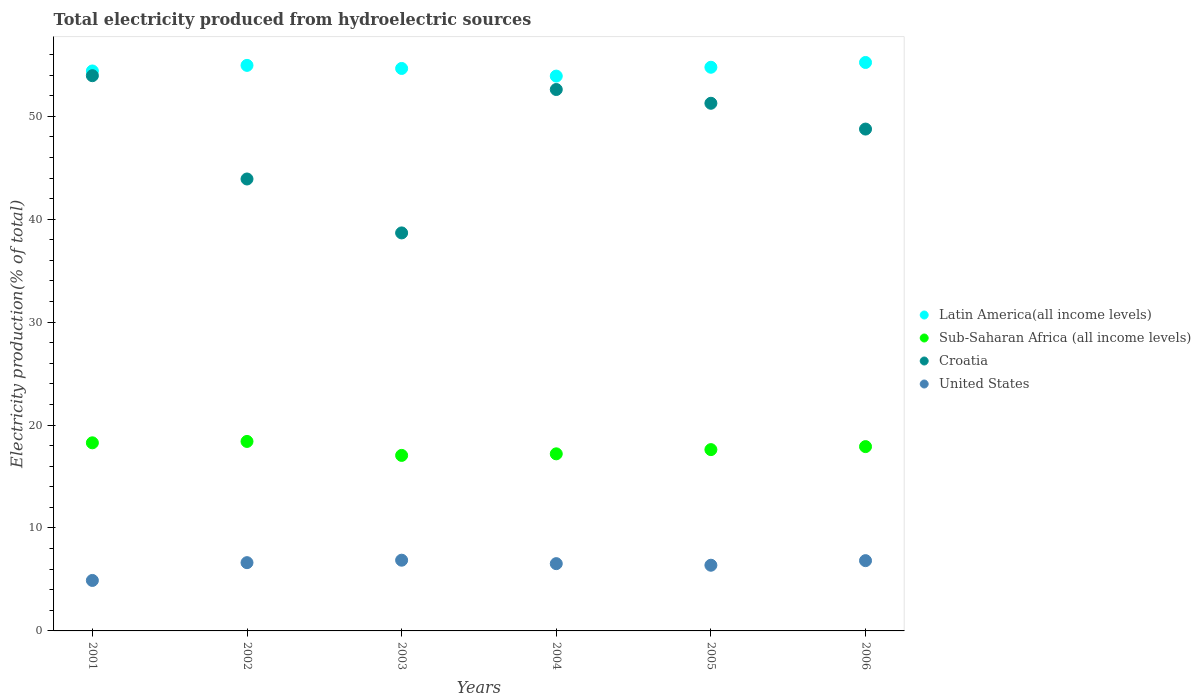How many different coloured dotlines are there?
Ensure brevity in your answer.  4. Is the number of dotlines equal to the number of legend labels?
Make the answer very short. Yes. What is the total electricity produced in Croatia in 2005?
Offer a terse response. 51.26. Across all years, what is the maximum total electricity produced in Sub-Saharan Africa (all income levels)?
Your answer should be very brief. 18.41. Across all years, what is the minimum total electricity produced in Latin America(all income levels)?
Keep it short and to the point. 53.9. In which year was the total electricity produced in United States maximum?
Your response must be concise. 2003. What is the total total electricity produced in Sub-Saharan Africa (all income levels) in the graph?
Ensure brevity in your answer.  106.46. What is the difference between the total electricity produced in United States in 2001 and that in 2006?
Give a very brief answer. -1.92. What is the difference between the total electricity produced in United States in 2005 and the total electricity produced in Latin America(all income levels) in 2001?
Provide a short and direct response. -48.02. What is the average total electricity produced in Croatia per year?
Give a very brief answer. 48.19. In the year 2003, what is the difference between the total electricity produced in United States and total electricity produced in Sub-Saharan Africa (all income levels)?
Make the answer very short. -10.18. In how many years, is the total electricity produced in United States greater than 20 %?
Provide a succinct answer. 0. What is the ratio of the total electricity produced in Latin America(all income levels) in 2001 to that in 2005?
Provide a succinct answer. 0.99. Is the total electricity produced in Croatia in 2001 less than that in 2002?
Your response must be concise. No. Is the difference between the total electricity produced in United States in 2002 and 2006 greater than the difference between the total electricity produced in Sub-Saharan Africa (all income levels) in 2002 and 2006?
Provide a short and direct response. No. What is the difference between the highest and the second highest total electricity produced in Sub-Saharan Africa (all income levels)?
Ensure brevity in your answer.  0.13. What is the difference between the highest and the lowest total electricity produced in Sub-Saharan Africa (all income levels)?
Ensure brevity in your answer.  1.36. Is the sum of the total electricity produced in United States in 2001 and 2004 greater than the maximum total electricity produced in Latin America(all income levels) across all years?
Offer a terse response. No. Is it the case that in every year, the sum of the total electricity produced in Sub-Saharan Africa (all income levels) and total electricity produced in Croatia  is greater than the total electricity produced in United States?
Provide a succinct answer. Yes. Is the total electricity produced in Croatia strictly greater than the total electricity produced in United States over the years?
Keep it short and to the point. Yes. How many dotlines are there?
Your response must be concise. 4. What is the difference between two consecutive major ticks on the Y-axis?
Provide a short and direct response. 10. Are the values on the major ticks of Y-axis written in scientific E-notation?
Offer a terse response. No. Does the graph contain any zero values?
Provide a short and direct response. No. Does the graph contain grids?
Keep it short and to the point. No. Where does the legend appear in the graph?
Your answer should be very brief. Center right. How many legend labels are there?
Offer a very short reply. 4. How are the legend labels stacked?
Make the answer very short. Vertical. What is the title of the graph?
Make the answer very short. Total electricity produced from hydroelectric sources. What is the label or title of the Y-axis?
Your answer should be very brief. Electricity production(% of total). What is the Electricity production(% of total) of Latin America(all income levels) in 2001?
Keep it short and to the point. 54.4. What is the Electricity production(% of total) in Sub-Saharan Africa (all income levels) in 2001?
Offer a terse response. 18.27. What is the Electricity production(% of total) of Croatia in 2001?
Ensure brevity in your answer.  53.94. What is the Electricity production(% of total) of United States in 2001?
Give a very brief answer. 4.9. What is the Electricity production(% of total) of Latin America(all income levels) in 2002?
Your answer should be compact. 54.94. What is the Electricity production(% of total) of Sub-Saharan Africa (all income levels) in 2002?
Your answer should be compact. 18.41. What is the Electricity production(% of total) of Croatia in 2002?
Ensure brevity in your answer.  43.91. What is the Electricity production(% of total) in United States in 2002?
Provide a short and direct response. 6.63. What is the Electricity production(% of total) in Latin America(all income levels) in 2003?
Ensure brevity in your answer.  54.65. What is the Electricity production(% of total) in Sub-Saharan Africa (all income levels) in 2003?
Provide a short and direct response. 17.05. What is the Electricity production(% of total) of Croatia in 2003?
Make the answer very short. 38.67. What is the Electricity production(% of total) of United States in 2003?
Your answer should be very brief. 6.87. What is the Electricity production(% of total) of Latin America(all income levels) in 2004?
Ensure brevity in your answer.  53.9. What is the Electricity production(% of total) in Sub-Saharan Africa (all income levels) in 2004?
Your answer should be very brief. 17.2. What is the Electricity production(% of total) of Croatia in 2004?
Your response must be concise. 52.6. What is the Electricity production(% of total) of United States in 2004?
Provide a short and direct response. 6.54. What is the Electricity production(% of total) in Latin America(all income levels) in 2005?
Your answer should be very brief. 54.76. What is the Electricity production(% of total) of Sub-Saharan Africa (all income levels) in 2005?
Give a very brief answer. 17.61. What is the Electricity production(% of total) of Croatia in 2005?
Offer a terse response. 51.26. What is the Electricity production(% of total) in United States in 2005?
Offer a very short reply. 6.38. What is the Electricity production(% of total) of Latin America(all income levels) in 2006?
Provide a short and direct response. 55.23. What is the Electricity production(% of total) in Sub-Saharan Africa (all income levels) in 2006?
Give a very brief answer. 17.91. What is the Electricity production(% of total) of Croatia in 2006?
Ensure brevity in your answer.  48.76. What is the Electricity production(% of total) of United States in 2006?
Ensure brevity in your answer.  6.83. Across all years, what is the maximum Electricity production(% of total) in Latin America(all income levels)?
Your answer should be very brief. 55.23. Across all years, what is the maximum Electricity production(% of total) of Sub-Saharan Africa (all income levels)?
Make the answer very short. 18.41. Across all years, what is the maximum Electricity production(% of total) in Croatia?
Your answer should be compact. 53.94. Across all years, what is the maximum Electricity production(% of total) in United States?
Your answer should be compact. 6.87. Across all years, what is the minimum Electricity production(% of total) of Latin America(all income levels)?
Provide a short and direct response. 53.9. Across all years, what is the minimum Electricity production(% of total) of Sub-Saharan Africa (all income levels)?
Provide a succinct answer. 17.05. Across all years, what is the minimum Electricity production(% of total) in Croatia?
Provide a succinct answer. 38.67. Across all years, what is the minimum Electricity production(% of total) of United States?
Ensure brevity in your answer.  4.9. What is the total Electricity production(% of total) in Latin America(all income levels) in the graph?
Make the answer very short. 327.89. What is the total Electricity production(% of total) in Sub-Saharan Africa (all income levels) in the graph?
Offer a terse response. 106.46. What is the total Electricity production(% of total) in Croatia in the graph?
Provide a succinct answer. 289.14. What is the total Electricity production(% of total) in United States in the graph?
Make the answer very short. 38.15. What is the difference between the Electricity production(% of total) in Latin America(all income levels) in 2001 and that in 2002?
Give a very brief answer. -0.54. What is the difference between the Electricity production(% of total) of Sub-Saharan Africa (all income levels) in 2001 and that in 2002?
Your answer should be very brief. -0.13. What is the difference between the Electricity production(% of total) of Croatia in 2001 and that in 2002?
Provide a succinct answer. 10.04. What is the difference between the Electricity production(% of total) in United States in 2001 and that in 2002?
Give a very brief answer. -1.73. What is the difference between the Electricity production(% of total) of Latin America(all income levels) in 2001 and that in 2003?
Give a very brief answer. -0.24. What is the difference between the Electricity production(% of total) in Sub-Saharan Africa (all income levels) in 2001 and that in 2003?
Provide a succinct answer. 1.22. What is the difference between the Electricity production(% of total) of Croatia in 2001 and that in 2003?
Offer a very short reply. 15.27. What is the difference between the Electricity production(% of total) of United States in 2001 and that in 2003?
Offer a terse response. -1.97. What is the difference between the Electricity production(% of total) of Latin America(all income levels) in 2001 and that in 2004?
Ensure brevity in your answer.  0.5. What is the difference between the Electricity production(% of total) in Sub-Saharan Africa (all income levels) in 2001 and that in 2004?
Your answer should be compact. 1.07. What is the difference between the Electricity production(% of total) of Croatia in 2001 and that in 2004?
Your answer should be very brief. 1.34. What is the difference between the Electricity production(% of total) of United States in 2001 and that in 2004?
Give a very brief answer. -1.63. What is the difference between the Electricity production(% of total) of Latin America(all income levels) in 2001 and that in 2005?
Your response must be concise. -0.36. What is the difference between the Electricity production(% of total) of Sub-Saharan Africa (all income levels) in 2001 and that in 2005?
Your answer should be very brief. 0.66. What is the difference between the Electricity production(% of total) of Croatia in 2001 and that in 2005?
Provide a succinct answer. 2.68. What is the difference between the Electricity production(% of total) of United States in 2001 and that in 2005?
Your answer should be very brief. -1.48. What is the difference between the Electricity production(% of total) in Latin America(all income levels) in 2001 and that in 2006?
Your response must be concise. -0.83. What is the difference between the Electricity production(% of total) in Sub-Saharan Africa (all income levels) in 2001 and that in 2006?
Ensure brevity in your answer.  0.37. What is the difference between the Electricity production(% of total) in Croatia in 2001 and that in 2006?
Keep it short and to the point. 5.19. What is the difference between the Electricity production(% of total) of United States in 2001 and that in 2006?
Make the answer very short. -1.92. What is the difference between the Electricity production(% of total) in Latin America(all income levels) in 2002 and that in 2003?
Provide a short and direct response. 0.3. What is the difference between the Electricity production(% of total) in Sub-Saharan Africa (all income levels) in 2002 and that in 2003?
Offer a terse response. 1.36. What is the difference between the Electricity production(% of total) of Croatia in 2002 and that in 2003?
Your response must be concise. 5.24. What is the difference between the Electricity production(% of total) of United States in 2002 and that in 2003?
Offer a terse response. -0.24. What is the difference between the Electricity production(% of total) of Latin America(all income levels) in 2002 and that in 2004?
Offer a terse response. 1.04. What is the difference between the Electricity production(% of total) in Sub-Saharan Africa (all income levels) in 2002 and that in 2004?
Make the answer very short. 1.2. What is the difference between the Electricity production(% of total) of Croatia in 2002 and that in 2004?
Provide a short and direct response. -8.69. What is the difference between the Electricity production(% of total) of United States in 2002 and that in 2004?
Your answer should be very brief. 0.1. What is the difference between the Electricity production(% of total) in Latin America(all income levels) in 2002 and that in 2005?
Provide a succinct answer. 0.18. What is the difference between the Electricity production(% of total) of Sub-Saharan Africa (all income levels) in 2002 and that in 2005?
Your response must be concise. 0.79. What is the difference between the Electricity production(% of total) of Croatia in 2002 and that in 2005?
Your answer should be very brief. -7.36. What is the difference between the Electricity production(% of total) in Latin America(all income levels) in 2002 and that in 2006?
Offer a very short reply. -0.28. What is the difference between the Electricity production(% of total) in Sub-Saharan Africa (all income levels) in 2002 and that in 2006?
Give a very brief answer. 0.5. What is the difference between the Electricity production(% of total) in Croatia in 2002 and that in 2006?
Your answer should be compact. -4.85. What is the difference between the Electricity production(% of total) in United States in 2002 and that in 2006?
Offer a terse response. -0.2. What is the difference between the Electricity production(% of total) of Latin America(all income levels) in 2003 and that in 2004?
Provide a short and direct response. 0.74. What is the difference between the Electricity production(% of total) of Sub-Saharan Africa (all income levels) in 2003 and that in 2004?
Your answer should be compact. -0.15. What is the difference between the Electricity production(% of total) in Croatia in 2003 and that in 2004?
Ensure brevity in your answer.  -13.93. What is the difference between the Electricity production(% of total) in United States in 2003 and that in 2004?
Keep it short and to the point. 0.34. What is the difference between the Electricity production(% of total) in Latin America(all income levels) in 2003 and that in 2005?
Keep it short and to the point. -0.12. What is the difference between the Electricity production(% of total) in Sub-Saharan Africa (all income levels) in 2003 and that in 2005?
Provide a succinct answer. -0.56. What is the difference between the Electricity production(% of total) of Croatia in 2003 and that in 2005?
Offer a terse response. -12.6. What is the difference between the Electricity production(% of total) of United States in 2003 and that in 2005?
Ensure brevity in your answer.  0.49. What is the difference between the Electricity production(% of total) in Latin America(all income levels) in 2003 and that in 2006?
Your answer should be compact. -0.58. What is the difference between the Electricity production(% of total) in Sub-Saharan Africa (all income levels) in 2003 and that in 2006?
Your answer should be very brief. -0.85. What is the difference between the Electricity production(% of total) of Croatia in 2003 and that in 2006?
Offer a terse response. -10.09. What is the difference between the Electricity production(% of total) in United States in 2003 and that in 2006?
Make the answer very short. 0.04. What is the difference between the Electricity production(% of total) of Latin America(all income levels) in 2004 and that in 2005?
Ensure brevity in your answer.  -0.86. What is the difference between the Electricity production(% of total) in Sub-Saharan Africa (all income levels) in 2004 and that in 2005?
Your answer should be very brief. -0.41. What is the difference between the Electricity production(% of total) of Croatia in 2004 and that in 2005?
Provide a succinct answer. 1.34. What is the difference between the Electricity production(% of total) in United States in 2004 and that in 2005?
Offer a very short reply. 0.15. What is the difference between the Electricity production(% of total) of Latin America(all income levels) in 2004 and that in 2006?
Make the answer very short. -1.32. What is the difference between the Electricity production(% of total) in Sub-Saharan Africa (all income levels) in 2004 and that in 2006?
Your answer should be very brief. -0.7. What is the difference between the Electricity production(% of total) in Croatia in 2004 and that in 2006?
Your answer should be compact. 3.84. What is the difference between the Electricity production(% of total) of United States in 2004 and that in 2006?
Your answer should be very brief. -0.29. What is the difference between the Electricity production(% of total) in Latin America(all income levels) in 2005 and that in 2006?
Keep it short and to the point. -0.46. What is the difference between the Electricity production(% of total) in Sub-Saharan Africa (all income levels) in 2005 and that in 2006?
Offer a very short reply. -0.29. What is the difference between the Electricity production(% of total) in Croatia in 2005 and that in 2006?
Your answer should be compact. 2.51. What is the difference between the Electricity production(% of total) of United States in 2005 and that in 2006?
Make the answer very short. -0.45. What is the difference between the Electricity production(% of total) in Latin America(all income levels) in 2001 and the Electricity production(% of total) in Sub-Saharan Africa (all income levels) in 2002?
Your answer should be compact. 35.99. What is the difference between the Electricity production(% of total) of Latin America(all income levels) in 2001 and the Electricity production(% of total) of Croatia in 2002?
Your answer should be very brief. 10.49. What is the difference between the Electricity production(% of total) in Latin America(all income levels) in 2001 and the Electricity production(% of total) in United States in 2002?
Offer a very short reply. 47.77. What is the difference between the Electricity production(% of total) in Sub-Saharan Africa (all income levels) in 2001 and the Electricity production(% of total) in Croatia in 2002?
Your response must be concise. -25.63. What is the difference between the Electricity production(% of total) of Sub-Saharan Africa (all income levels) in 2001 and the Electricity production(% of total) of United States in 2002?
Provide a short and direct response. 11.64. What is the difference between the Electricity production(% of total) in Croatia in 2001 and the Electricity production(% of total) in United States in 2002?
Your answer should be compact. 47.31. What is the difference between the Electricity production(% of total) in Latin America(all income levels) in 2001 and the Electricity production(% of total) in Sub-Saharan Africa (all income levels) in 2003?
Your response must be concise. 37.35. What is the difference between the Electricity production(% of total) in Latin America(all income levels) in 2001 and the Electricity production(% of total) in Croatia in 2003?
Provide a succinct answer. 15.73. What is the difference between the Electricity production(% of total) of Latin America(all income levels) in 2001 and the Electricity production(% of total) of United States in 2003?
Provide a short and direct response. 47.53. What is the difference between the Electricity production(% of total) in Sub-Saharan Africa (all income levels) in 2001 and the Electricity production(% of total) in Croatia in 2003?
Provide a succinct answer. -20.39. What is the difference between the Electricity production(% of total) in Sub-Saharan Africa (all income levels) in 2001 and the Electricity production(% of total) in United States in 2003?
Your answer should be compact. 11.4. What is the difference between the Electricity production(% of total) of Croatia in 2001 and the Electricity production(% of total) of United States in 2003?
Give a very brief answer. 47.07. What is the difference between the Electricity production(% of total) of Latin America(all income levels) in 2001 and the Electricity production(% of total) of Sub-Saharan Africa (all income levels) in 2004?
Provide a short and direct response. 37.2. What is the difference between the Electricity production(% of total) of Latin America(all income levels) in 2001 and the Electricity production(% of total) of Croatia in 2004?
Your response must be concise. 1.8. What is the difference between the Electricity production(% of total) in Latin America(all income levels) in 2001 and the Electricity production(% of total) in United States in 2004?
Provide a short and direct response. 47.87. What is the difference between the Electricity production(% of total) in Sub-Saharan Africa (all income levels) in 2001 and the Electricity production(% of total) in Croatia in 2004?
Provide a short and direct response. -34.33. What is the difference between the Electricity production(% of total) in Sub-Saharan Africa (all income levels) in 2001 and the Electricity production(% of total) in United States in 2004?
Keep it short and to the point. 11.74. What is the difference between the Electricity production(% of total) of Croatia in 2001 and the Electricity production(% of total) of United States in 2004?
Provide a succinct answer. 47.41. What is the difference between the Electricity production(% of total) of Latin America(all income levels) in 2001 and the Electricity production(% of total) of Sub-Saharan Africa (all income levels) in 2005?
Make the answer very short. 36.79. What is the difference between the Electricity production(% of total) in Latin America(all income levels) in 2001 and the Electricity production(% of total) in Croatia in 2005?
Your answer should be very brief. 3.14. What is the difference between the Electricity production(% of total) in Latin America(all income levels) in 2001 and the Electricity production(% of total) in United States in 2005?
Your answer should be very brief. 48.02. What is the difference between the Electricity production(% of total) of Sub-Saharan Africa (all income levels) in 2001 and the Electricity production(% of total) of Croatia in 2005?
Offer a very short reply. -32.99. What is the difference between the Electricity production(% of total) of Sub-Saharan Africa (all income levels) in 2001 and the Electricity production(% of total) of United States in 2005?
Give a very brief answer. 11.89. What is the difference between the Electricity production(% of total) of Croatia in 2001 and the Electricity production(% of total) of United States in 2005?
Your answer should be compact. 47.56. What is the difference between the Electricity production(% of total) in Latin America(all income levels) in 2001 and the Electricity production(% of total) in Sub-Saharan Africa (all income levels) in 2006?
Your response must be concise. 36.49. What is the difference between the Electricity production(% of total) in Latin America(all income levels) in 2001 and the Electricity production(% of total) in Croatia in 2006?
Provide a short and direct response. 5.64. What is the difference between the Electricity production(% of total) of Latin America(all income levels) in 2001 and the Electricity production(% of total) of United States in 2006?
Your response must be concise. 47.57. What is the difference between the Electricity production(% of total) of Sub-Saharan Africa (all income levels) in 2001 and the Electricity production(% of total) of Croatia in 2006?
Make the answer very short. -30.48. What is the difference between the Electricity production(% of total) in Sub-Saharan Africa (all income levels) in 2001 and the Electricity production(% of total) in United States in 2006?
Offer a terse response. 11.45. What is the difference between the Electricity production(% of total) of Croatia in 2001 and the Electricity production(% of total) of United States in 2006?
Provide a short and direct response. 47.12. What is the difference between the Electricity production(% of total) of Latin America(all income levels) in 2002 and the Electricity production(% of total) of Sub-Saharan Africa (all income levels) in 2003?
Offer a terse response. 37.89. What is the difference between the Electricity production(% of total) in Latin America(all income levels) in 2002 and the Electricity production(% of total) in Croatia in 2003?
Provide a succinct answer. 16.28. What is the difference between the Electricity production(% of total) of Latin America(all income levels) in 2002 and the Electricity production(% of total) of United States in 2003?
Your answer should be compact. 48.07. What is the difference between the Electricity production(% of total) in Sub-Saharan Africa (all income levels) in 2002 and the Electricity production(% of total) in Croatia in 2003?
Give a very brief answer. -20.26. What is the difference between the Electricity production(% of total) in Sub-Saharan Africa (all income levels) in 2002 and the Electricity production(% of total) in United States in 2003?
Offer a very short reply. 11.54. What is the difference between the Electricity production(% of total) of Croatia in 2002 and the Electricity production(% of total) of United States in 2003?
Your answer should be compact. 37.04. What is the difference between the Electricity production(% of total) of Latin America(all income levels) in 2002 and the Electricity production(% of total) of Sub-Saharan Africa (all income levels) in 2004?
Keep it short and to the point. 37.74. What is the difference between the Electricity production(% of total) of Latin America(all income levels) in 2002 and the Electricity production(% of total) of Croatia in 2004?
Your answer should be compact. 2.34. What is the difference between the Electricity production(% of total) of Latin America(all income levels) in 2002 and the Electricity production(% of total) of United States in 2004?
Provide a short and direct response. 48.41. What is the difference between the Electricity production(% of total) in Sub-Saharan Africa (all income levels) in 2002 and the Electricity production(% of total) in Croatia in 2004?
Your answer should be compact. -34.19. What is the difference between the Electricity production(% of total) in Sub-Saharan Africa (all income levels) in 2002 and the Electricity production(% of total) in United States in 2004?
Offer a terse response. 11.87. What is the difference between the Electricity production(% of total) of Croatia in 2002 and the Electricity production(% of total) of United States in 2004?
Your answer should be compact. 37.37. What is the difference between the Electricity production(% of total) in Latin America(all income levels) in 2002 and the Electricity production(% of total) in Sub-Saharan Africa (all income levels) in 2005?
Ensure brevity in your answer.  37.33. What is the difference between the Electricity production(% of total) in Latin America(all income levels) in 2002 and the Electricity production(% of total) in Croatia in 2005?
Keep it short and to the point. 3.68. What is the difference between the Electricity production(% of total) of Latin America(all income levels) in 2002 and the Electricity production(% of total) of United States in 2005?
Offer a very short reply. 48.56. What is the difference between the Electricity production(% of total) in Sub-Saharan Africa (all income levels) in 2002 and the Electricity production(% of total) in Croatia in 2005?
Make the answer very short. -32.85. What is the difference between the Electricity production(% of total) of Sub-Saharan Africa (all income levels) in 2002 and the Electricity production(% of total) of United States in 2005?
Your response must be concise. 12.03. What is the difference between the Electricity production(% of total) of Croatia in 2002 and the Electricity production(% of total) of United States in 2005?
Ensure brevity in your answer.  37.52. What is the difference between the Electricity production(% of total) of Latin America(all income levels) in 2002 and the Electricity production(% of total) of Sub-Saharan Africa (all income levels) in 2006?
Provide a short and direct response. 37.04. What is the difference between the Electricity production(% of total) in Latin America(all income levels) in 2002 and the Electricity production(% of total) in Croatia in 2006?
Your answer should be very brief. 6.19. What is the difference between the Electricity production(% of total) in Latin America(all income levels) in 2002 and the Electricity production(% of total) in United States in 2006?
Offer a very short reply. 48.12. What is the difference between the Electricity production(% of total) in Sub-Saharan Africa (all income levels) in 2002 and the Electricity production(% of total) in Croatia in 2006?
Keep it short and to the point. -30.35. What is the difference between the Electricity production(% of total) of Sub-Saharan Africa (all income levels) in 2002 and the Electricity production(% of total) of United States in 2006?
Your answer should be very brief. 11.58. What is the difference between the Electricity production(% of total) in Croatia in 2002 and the Electricity production(% of total) in United States in 2006?
Provide a succinct answer. 37.08. What is the difference between the Electricity production(% of total) of Latin America(all income levels) in 2003 and the Electricity production(% of total) of Sub-Saharan Africa (all income levels) in 2004?
Your answer should be compact. 37.44. What is the difference between the Electricity production(% of total) of Latin America(all income levels) in 2003 and the Electricity production(% of total) of Croatia in 2004?
Your answer should be very brief. 2.04. What is the difference between the Electricity production(% of total) in Latin America(all income levels) in 2003 and the Electricity production(% of total) in United States in 2004?
Offer a terse response. 48.11. What is the difference between the Electricity production(% of total) of Sub-Saharan Africa (all income levels) in 2003 and the Electricity production(% of total) of Croatia in 2004?
Make the answer very short. -35.55. What is the difference between the Electricity production(% of total) of Sub-Saharan Africa (all income levels) in 2003 and the Electricity production(% of total) of United States in 2004?
Your answer should be very brief. 10.52. What is the difference between the Electricity production(% of total) of Croatia in 2003 and the Electricity production(% of total) of United States in 2004?
Ensure brevity in your answer.  32.13. What is the difference between the Electricity production(% of total) in Latin America(all income levels) in 2003 and the Electricity production(% of total) in Sub-Saharan Africa (all income levels) in 2005?
Make the answer very short. 37.03. What is the difference between the Electricity production(% of total) of Latin America(all income levels) in 2003 and the Electricity production(% of total) of Croatia in 2005?
Ensure brevity in your answer.  3.38. What is the difference between the Electricity production(% of total) in Latin America(all income levels) in 2003 and the Electricity production(% of total) in United States in 2005?
Your answer should be compact. 48.26. What is the difference between the Electricity production(% of total) of Sub-Saharan Africa (all income levels) in 2003 and the Electricity production(% of total) of Croatia in 2005?
Your answer should be very brief. -34.21. What is the difference between the Electricity production(% of total) in Sub-Saharan Africa (all income levels) in 2003 and the Electricity production(% of total) in United States in 2005?
Provide a short and direct response. 10.67. What is the difference between the Electricity production(% of total) in Croatia in 2003 and the Electricity production(% of total) in United States in 2005?
Your response must be concise. 32.29. What is the difference between the Electricity production(% of total) of Latin America(all income levels) in 2003 and the Electricity production(% of total) of Sub-Saharan Africa (all income levels) in 2006?
Ensure brevity in your answer.  36.74. What is the difference between the Electricity production(% of total) of Latin America(all income levels) in 2003 and the Electricity production(% of total) of Croatia in 2006?
Offer a terse response. 5.89. What is the difference between the Electricity production(% of total) of Latin America(all income levels) in 2003 and the Electricity production(% of total) of United States in 2006?
Give a very brief answer. 47.82. What is the difference between the Electricity production(% of total) in Sub-Saharan Africa (all income levels) in 2003 and the Electricity production(% of total) in Croatia in 2006?
Provide a succinct answer. -31.7. What is the difference between the Electricity production(% of total) of Sub-Saharan Africa (all income levels) in 2003 and the Electricity production(% of total) of United States in 2006?
Ensure brevity in your answer.  10.23. What is the difference between the Electricity production(% of total) in Croatia in 2003 and the Electricity production(% of total) in United States in 2006?
Offer a terse response. 31.84. What is the difference between the Electricity production(% of total) in Latin America(all income levels) in 2004 and the Electricity production(% of total) in Sub-Saharan Africa (all income levels) in 2005?
Your answer should be very brief. 36.29. What is the difference between the Electricity production(% of total) in Latin America(all income levels) in 2004 and the Electricity production(% of total) in Croatia in 2005?
Make the answer very short. 2.64. What is the difference between the Electricity production(% of total) in Latin America(all income levels) in 2004 and the Electricity production(% of total) in United States in 2005?
Make the answer very short. 47.52. What is the difference between the Electricity production(% of total) of Sub-Saharan Africa (all income levels) in 2004 and the Electricity production(% of total) of Croatia in 2005?
Provide a succinct answer. -34.06. What is the difference between the Electricity production(% of total) of Sub-Saharan Africa (all income levels) in 2004 and the Electricity production(% of total) of United States in 2005?
Ensure brevity in your answer.  10.82. What is the difference between the Electricity production(% of total) of Croatia in 2004 and the Electricity production(% of total) of United States in 2005?
Keep it short and to the point. 46.22. What is the difference between the Electricity production(% of total) of Latin America(all income levels) in 2004 and the Electricity production(% of total) of Sub-Saharan Africa (all income levels) in 2006?
Make the answer very short. 36. What is the difference between the Electricity production(% of total) of Latin America(all income levels) in 2004 and the Electricity production(% of total) of Croatia in 2006?
Make the answer very short. 5.15. What is the difference between the Electricity production(% of total) of Latin America(all income levels) in 2004 and the Electricity production(% of total) of United States in 2006?
Provide a short and direct response. 47.08. What is the difference between the Electricity production(% of total) in Sub-Saharan Africa (all income levels) in 2004 and the Electricity production(% of total) in Croatia in 2006?
Your response must be concise. -31.55. What is the difference between the Electricity production(% of total) of Sub-Saharan Africa (all income levels) in 2004 and the Electricity production(% of total) of United States in 2006?
Your answer should be very brief. 10.38. What is the difference between the Electricity production(% of total) in Croatia in 2004 and the Electricity production(% of total) in United States in 2006?
Your response must be concise. 45.77. What is the difference between the Electricity production(% of total) in Latin America(all income levels) in 2005 and the Electricity production(% of total) in Sub-Saharan Africa (all income levels) in 2006?
Make the answer very short. 36.86. What is the difference between the Electricity production(% of total) of Latin America(all income levels) in 2005 and the Electricity production(% of total) of Croatia in 2006?
Give a very brief answer. 6.01. What is the difference between the Electricity production(% of total) in Latin America(all income levels) in 2005 and the Electricity production(% of total) in United States in 2006?
Provide a short and direct response. 47.94. What is the difference between the Electricity production(% of total) in Sub-Saharan Africa (all income levels) in 2005 and the Electricity production(% of total) in Croatia in 2006?
Your answer should be very brief. -31.14. What is the difference between the Electricity production(% of total) of Sub-Saharan Africa (all income levels) in 2005 and the Electricity production(% of total) of United States in 2006?
Ensure brevity in your answer.  10.79. What is the difference between the Electricity production(% of total) of Croatia in 2005 and the Electricity production(% of total) of United States in 2006?
Make the answer very short. 44.44. What is the average Electricity production(% of total) of Latin America(all income levels) per year?
Your response must be concise. 54.65. What is the average Electricity production(% of total) of Sub-Saharan Africa (all income levels) per year?
Ensure brevity in your answer.  17.74. What is the average Electricity production(% of total) in Croatia per year?
Your answer should be compact. 48.19. What is the average Electricity production(% of total) in United States per year?
Your response must be concise. 6.36. In the year 2001, what is the difference between the Electricity production(% of total) in Latin America(all income levels) and Electricity production(% of total) in Sub-Saharan Africa (all income levels)?
Offer a terse response. 36.13. In the year 2001, what is the difference between the Electricity production(% of total) in Latin America(all income levels) and Electricity production(% of total) in Croatia?
Make the answer very short. 0.46. In the year 2001, what is the difference between the Electricity production(% of total) of Latin America(all income levels) and Electricity production(% of total) of United States?
Provide a short and direct response. 49.5. In the year 2001, what is the difference between the Electricity production(% of total) in Sub-Saharan Africa (all income levels) and Electricity production(% of total) in Croatia?
Make the answer very short. -35.67. In the year 2001, what is the difference between the Electricity production(% of total) in Sub-Saharan Africa (all income levels) and Electricity production(% of total) in United States?
Your answer should be compact. 13.37. In the year 2001, what is the difference between the Electricity production(% of total) in Croatia and Electricity production(% of total) in United States?
Ensure brevity in your answer.  49.04. In the year 2002, what is the difference between the Electricity production(% of total) of Latin America(all income levels) and Electricity production(% of total) of Sub-Saharan Africa (all income levels)?
Your answer should be very brief. 36.54. In the year 2002, what is the difference between the Electricity production(% of total) in Latin America(all income levels) and Electricity production(% of total) in Croatia?
Ensure brevity in your answer.  11.04. In the year 2002, what is the difference between the Electricity production(% of total) of Latin America(all income levels) and Electricity production(% of total) of United States?
Provide a short and direct response. 48.31. In the year 2002, what is the difference between the Electricity production(% of total) in Sub-Saharan Africa (all income levels) and Electricity production(% of total) in Croatia?
Offer a very short reply. -25.5. In the year 2002, what is the difference between the Electricity production(% of total) of Sub-Saharan Africa (all income levels) and Electricity production(% of total) of United States?
Your response must be concise. 11.78. In the year 2002, what is the difference between the Electricity production(% of total) of Croatia and Electricity production(% of total) of United States?
Offer a terse response. 37.27. In the year 2003, what is the difference between the Electricity production(% of total) of Latin America(all income levels) and Electricity production(% of total) of Sub-Saharan Africa (all income levels)?
Make the answer very short. 37.59. In the year 2003, what is the difference between the Electricity production(% of total) in Latin America(all income levels) and Electricity production(% of total) in Croatia?
Make the answer very short. 15.98. In the year 2003, what is the difference between the Electricity production(% of total) in Latin America(all income levels) and Electricity production(% of total) in United States?
Give a very brief answer. 47.77. In the year 2003, what is the difference between the Electricity production(% of total) of Sub-Saharan Africa (all income levels) and Electricity production(% of total) of Croatia?
Offer a terse response. -21.62. In the year 2003, what is the difference between the Electricity production(% of total) of Sub-Saharan Africa (all income levels) and Electricity production(% of total) of United States?
Make the answer very short. 10.18. In the year 2003, what is the difference between the Electricity production(% of total) of Croatia and Electricity production(% of total) of United States?
Provide a short and direct response. 31.8. In the year 2004, what is the difference between the Electricity production(% of total) of Latin America(all income levels) and Electricity production(% of total) of Sub-Saharan Africa (all income levels)?
Your answer should be very brief. 36.7. In the year 2004, what is the difference between the Electricity production(% of total) in Latin America(all income levels) and Electricity production(% of total) in Croatia?
Offer a very short reply. 1.3. In the year 2004, what is the difference between the Electricity production(% of total) in Latin America(all income levels) and Electricity production(% of total) in United States?
Your answer should be compact. 47.37. In the year 2004, what is the difference between the Electricity production(% of total) in Sub-Saharan Africa (all income levels) and Electricity production(% of total) in Croatia?
Offer a very short reply. -35.4. In the year 2004, what is the difference between the Electricity production(% of total) of Sub-Saharan Africa (all income levels) and Electricity production(% of total) of United States?
Ensure brevity in your answer.  10.67. In the year 2004, what is the difference between the Electricity production(% of total) of Croatia and Electricity production(% of total) of United States?
Offer a terse response. 46.06. In the year 2005, what is the difference between the Electricity production(% of total) in Latin America(all income levels) and Electricity production(% of total) in Sub-Saharan Africa (all income levels)?
Your answer should be compact. 37.15. In the year 2005, what is the difference between the Electricity production(% of total) in Latin America(all income levels) and Electricity production(% of total) in Croatia?
Your answer should be very brief. 3.5. In the year 2005, what is the difference between the Electricity production(% of total) in Latin America(all income levels) and Electricity production(% of total) in United States?
Keep it short and to the point. 48.38. In the year 2005, what is the difference between the Electricity production(% of total) in Sub-Saharan Africa (all income levels) and Electricity production(% of total) in Croatia?
Offer a terse response. -33.65. In the year 2005, what is the difference between the Electricity production(% of total) in Sub-Saharan Africa (all income levels) and Electricity production(% of total) in United States?
Make the answer very short. 11.23. In the year 2005, what is the difference between the Electricity production(% of total) in Croatia and Electricity production(% of total) in United States?
Provide a short and direct response. 44.88. In the year 2006, what is the difference between the Electricity production(% of total) of Latin America(all income levels) and Electricity production(% of total) of Sub-Saharan Africa (all income levels)?
Ensure brevity in your answer.  37.32. In the year 2006, what is the difference between the Electricity production(% of total) in Latin America(all income levels) and Electricity production(% of total) in Croatia?
Your answer should be very brief. 6.47. In the year 2006, what is the difference between the Electricity production(% of total) of Latin America(all income levels) and Electricity production(% of total) of United States?
Provide a succinct answer. 48.4. In the year 2006, what is the difference between the Electricity production(% of total) in Sub-Saharan Africa (all income levels) and Electricity production(% of total) in Croatia?
Your answer should be very brief. -30.85. In the year 2006, what is the difference between the Electricity production(% of total) of Sub-Saharan Africa (all income levels) and Electricity production(% of total) of United States?
Your answer should be very brief. 11.08. In the year 2006, what is the difference between the Electricity production(% of total) in Croatia and Electricity production(% of total) in United States?
Your answer should be very brief. 41.93. What is the ratio of the Electricity production(% of total) of Latin America(all income levels) in 2001 to that in 2002?
Offer a terse response. 0.99. What is the ratio of the Electricity production(% of total) of Croatia in 2001 to that in 2002?
Your response must be concise. 1.23. What is the ratio of the Electricity production(% of total) of United States in 2001 to that in 2002?
Give a very brief answer. 0.74. What is the ratio of the Electricity production(% of total) in Latin America(all income levels) in 2001 to that in 2003?
Offer a terse response. 1. What is the ratio of the Electricity production(% of total) of Sub-Saharan Africa (all income levels) in 2001 to that in 2003?
Your response must be concise. 1.07. What is the ratio of the Electricity production(% of total) of Croatia in 2001 to that in 2003?
Ensure brevity in your answer.  1.4. What is the ratio of the Electricity production(% of total) of United States in 2001 to that in 2003?
Ensure brevity in your answer.  0.71. What is the ratio of the Electricity production(% of total) in Latin America(all income levels) in 2001 to that in 2004?
Make the answer very short. 1.01. What is the ratio of the Electricity production(% of total) in Sub-Saharan Africa (all income levels) in 2001 to that in 2004?
Give a very brief answer. 1.06. What is the ratio of the Electricity production(% of total) of Croatia in 2001 to that in 2004?
Make the answer very short. 1.03. What is the ratio of the Electricity production(% of total) in United States in 2001 to that in 2004?
Provide a short and direct response. 0.75. What is the ratio of the Electricity production(% of total) in Sub-Saharan Africa (all income levels) in 2001 to that in 2005?
Give a very brief answer. 1.04. What is the ratio of the Electricity production(% of total) in Croatia in 2001 to that in 2005?
Your response must be concise. 1.05. What is the ratio of the Electricity production(% of total) in United States in 2001 to that in 2005?
Your answer should be compact. 0.77. What is the ratio of the Electricity production(% of total) in Sub-Saharan Africa (all income levels) in 2001 to that in 2006?
Keep it short and to the point. 1.02. What is the ratio of the Electricity production(% of total) of Croatia in 2001 to that in 2006?
Make the answer very short. 1.11. What is the ratio of the Electricity production(% of total) of United States in 2001 to that in 2006?
Offer a very short reply. 0.72. What is the ratio of the Electricity production(% of total) in Sub-Saharan Africa (all income levels) in 2002 to that in 2003?
Make the answer very short. 1.08. What is the ratio of the Electricity production(% of total) in Croatia in 2002 to that in 2003?
Your answer should be compact. 1.14. What is the ratio of the Electricity production(% of total) of United States in 2002 to that in 2003?
Provide a succinct answer. 0.97. What is the ratio of the Electricity production(% of total) in Latin America(all income levels) in 2002 to that in 2004?
Give a very brief answer. 1.02. What is the ratio of the Electricity production(% of total) in Sub-Saharan Africa (all income levels) in 2002 to that in 2004?
Keep it short and to the point. 1.07. What is the ratio of the Electricity production(% of total) in Croatia in 2002 to that in 2004?
Your response must be concise. 0.83. What is the ratio of the Electricity production(% of total) of United States in 2002 to that in 2004?
Give a very brief answer. 1.01. What is the ratio of the Electricity production(% of total) of Sub-Saharan Africa (all income levels) in 2002 to that in 2005?
Offer a very short reply. 1.05. What is the ratio of the Electricity production(% of total) of Croatia in 2002 to that in 2005?
Keep it short and to the point. 0.86. What is the ratio of the Electricity production(% of total) in United States in 2002 to that in 2005?
Make the answer very short. 1.04. What is the ratio of the Electricity production(% of total) in Latin America(all income levels) in 2002 to that in 2006?
Keep it short and to the point. 0.99. What is the ratio of the Electricity production(% of total) in Sub-Saharan Africa (all income levels) in 2002 to that in 2006?
Offer a very short reply. 1.03. What is the ratio of the Electricity production(% of total) of Croatia in 2002 to that in 2006?
Provide a succinct answer. 0.9. What is the ratio of the Electricity production(% of total) of United States in 2002 to that in 2006?
Make the answer very short. 0.97. What is the ratio of the Electricity production(% of total) in Latin America(all income levels) in 2003 to that in 2004?
Offer a terse response. 1.01. What is the ratio of the Electricity production(% of total) of Sub-Saharan Africa (all income levels) in 2003 to that in 2004?
Ensure brevity in your answer.  0.99. What is the ratio of the Electricity production(% of total) of Croatia in 2003 to that in 2004?
Provide a short and direct response. 0.74. What is the ratio of the Electricity production(% of total) of United States in 2003 to that in 2004?
Provide a succinct answer. 1.05. What is the ratio of the Electricity production(% of total) of Sub-Saharan Africa (all income levels) in 2003 to that in 2005?
Keep it short and to the point. 0.97. What is the ratio of the Electricity production(% of total) in Croatia in 2003 to that in 2005?
Make the answer very short. 0.75. What is the ratio of the Electricity production(% of total) of United States in 2003 to that in 2005?
Make the answer very short. 1.08. What is the ratio of the Electricity production(% of total) of Sub-Saharan Africa (all income levels) in 2003 to that in 2006?
Your response must be concise. 0.95. What is the ratio of the Electricity production(% of total) of Croatia in 2003 to that in 2006?
Make the answer very short. 0.79. What is the ratio of the Electricity production(% of total) of United States in 2003 to that in 2006?
Your response must be concise. 1.01. What is the ratio of the Electricity production(% of total) of Latin America(all income levels) in 2004 to that in 2005?
Give a very brief answer. 0.98. What is the ratio of the Electricity production(% of total) in Sub-Saharan Africa (all income levels) in 2004 to that in 2005?
Offer a terse response. 0.98. What is the ratio of the Electricity production(% of total) of Croatia in 2004 to that in 2005?
Your answer should be compact. 1.03. What is the ratio of the Electricity production(% of total) of United States in 2004 to that in 2005?
Provide a short and direct response. 1.02. What is the ratio of the Electricity production(% of total) in Latin America(all income levels) in 2004 to that in 2006?
Make the answer very short. 0.98. What is the ratio of the Electricity production(% of total) of Sub-Saharan Africa (all income levels) in 2004 to that in 2006?
Give a very brief answer. 0.96. What is the ratio of the Electricity production(% of total) of Croatia in 2004 to that in 2006?
Provide a succinct answer. 1.08. What is the ratio of the Electricity production(% of total) of United States in 2004 to that in 2006?
Give a very brief answer. 0.96. What is the ratio of the Electricity production(% of total) of Latin America(all income levels) in 2005 to that in 2006?
Your answer should be compact. 0.99. What is the ratio of the Electricity production(% of total) of Sub-Saharan Africa (all income levels) in 2005 to that in 2006?
Make the answer very short. 0.98. What is the ratio of the Electricity production(% of total) of Croatia in 2005 to that in 2006?
Your response must be concise. 1.05. What is the ratio of the Electricity production(% of total) of United States in 2005 to that in 2006?
Provide a succinct answer. 0.93. What is the difference between the highest and the second highest Electricity production(% of total) in Latin America(all income levels)?
Your answer should be very brief. 0.28. What is the difference between the highest and the second highest Electricity production(% of total) of Sub-Saharan Africa (all income levels)?
Offer a terse response. 0.13. What is the difference between the highest and the second highest Electricity production(% of total) in Croatia?
Give a very brief answer. 1.34. What is the difference between the highest and the second highest Electricity production(% of total) in United States?
Ensure brevity in your answer.  0.04. What is the difference between the highest and the lowest Electricity production(% of total) in Latin America(all income levels)?
Offer a very short reply. 1.32. What is the difference between the highest and the lowest Electricity production(% of total) of Sub-Saharan Africa (all income levels)?
Your answer should be compact. 1.36. What is the difference between the highest and the lowest Electricity production(% of total) of Croatia?
Keep it short and to the point. 15.27. What is the difference between the highest and the lowest Electricity production(% of total) of United States?
Your answer should be very brief. 1.97. 